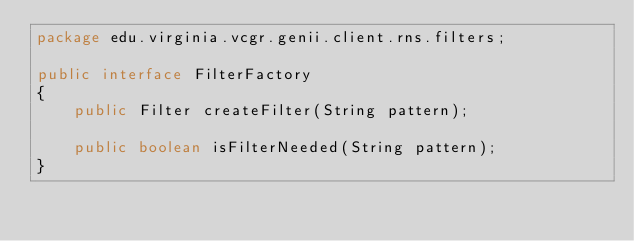Convert code to text. <code><loc_0><loc_0><loc_500><loc_500><_Java_>package edu.virginia.vcgr.genii.client.rns.filters;

public interface FilterFactory
{
	public Filter createFilter(String pattern);

	public boolean isFilterNeeded(String pattern);
}</code> 